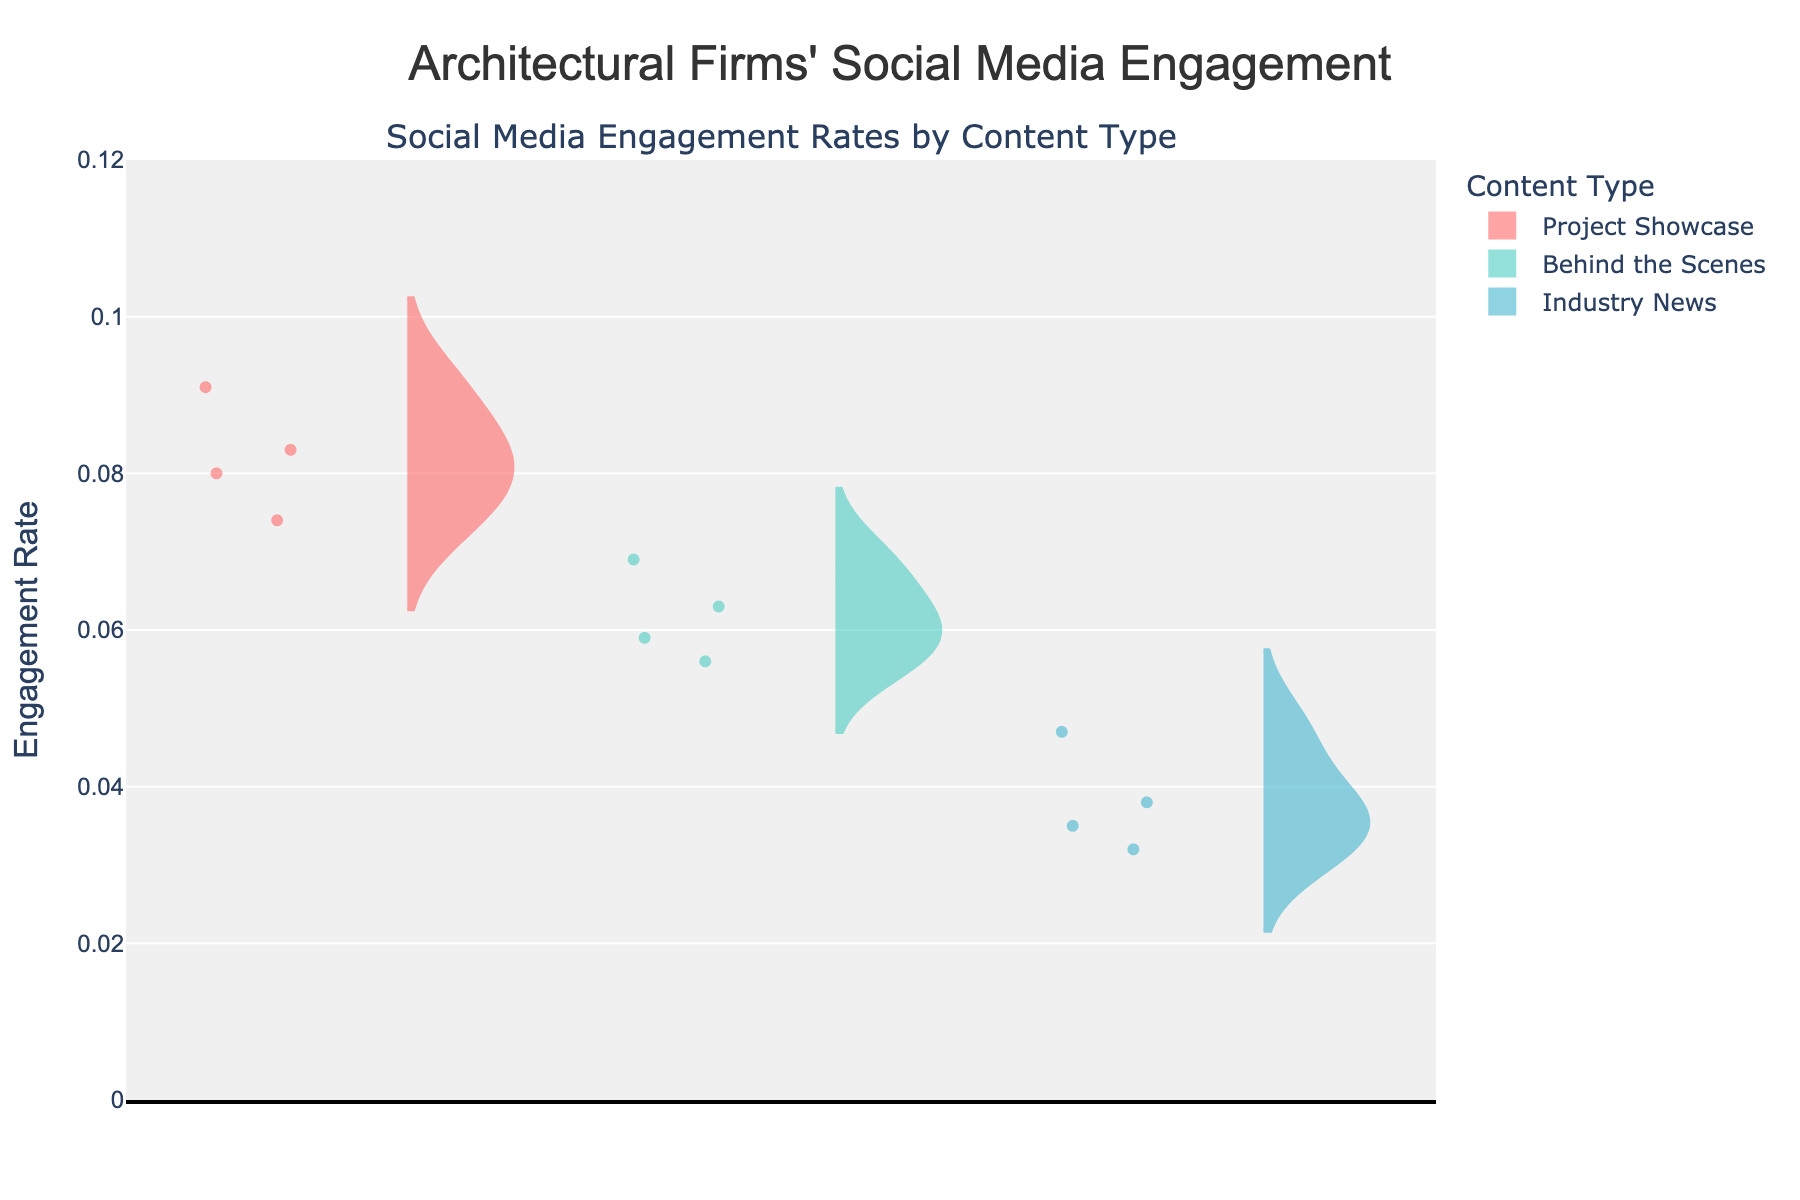What is the title of the chart? The title of the chart is prominently displayed at the top and reads "Architectural Firms' Social Media Engagement."
Answer: Architectural Firms' Social Media Engagement Which content type has the highest maximum engagement rate? By examining the peaks of the violin plots, Project Showcase has the highest maximum engagement rates across all content types.
Answer: Project Showcase What is the general range of engagement rates for the 'Industry News' content type? The range is visible within the violin plot for Industry News. It spans from about 0.03 to 0.047.
Answer: 0.03 to 0.047 Which content type shows the most variation in engagement rates? The width of the violin plots indicates the variation. Project Showcase, with the widest spread, indicates the most variation in engagement rates.
Answer: Project Showcase How do engagement rates for 'Behind the Scenes' content compare among the architectural firms? By comparing the different sections of the violin plots, Zaha Hadid Architects has the highest engagement, followed by Gensler and Foster + Partners.
Answer: Zaha Hadid Architects > Gensler > Foster + Partners What is the median engagement rate for 'Project Showcase' content? The median is marked by a line inside the violin plot for Project Showcase and is approximately at 0.08.
Answer: 0.08 Is there any content type with an engagement rate that exceeds 0.1? Observing the range of all violin plots, none of the engagement rates exceed 0.1.
Answer: No Which content type shows the least variability in engagement rate? The smallest spread indicates the least variability, which can be seen in the Industry News content type's violin plot.
Answer: Industry News Which architectural firm has the highest average engagement rate for 'Behind the Scenes' content? By analyzing the mean lines in the violin plots for Behind the Scenes, Zaha Hadid Architects has the highest average engagement rate.
Answer: Zaha Hadid Architects 